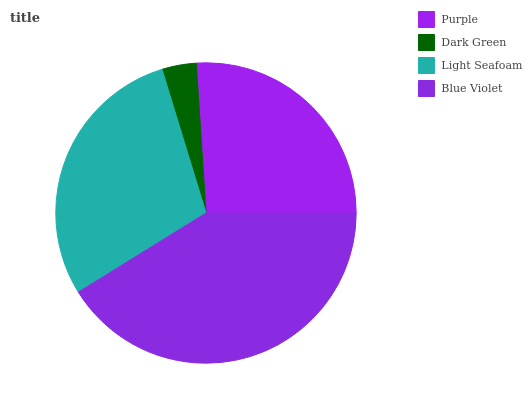Is Dark Green the minimum?
Answer yes or no. Yes. Is Blue Violet the maximum?
Answer yes or no. Yes. Is Light Seafoam the minimum?
Answer yes or no. No. Is Light Seafoam the maximum?
Answer yes or no. No. Is Light Seafoam greater than Dark Green?
Answer yes or no. Yes. Is Dark Green less than Light Seafoam?
Answer yes or no. Yes. Is Dark Green greater than Light Seafoam?
Answer yes or no. No. Is Light Seafoam less than Dark Green?
Answer yes or no. No. Is Light Seafoam the high median?
Answer yes or no. Yes. Is Purple the low median?
Answer yes or no. Yes. Is Dark Green the high median?
Answer yes or no. No. Is Dark Green the low median?
Answer yes or no. No. 